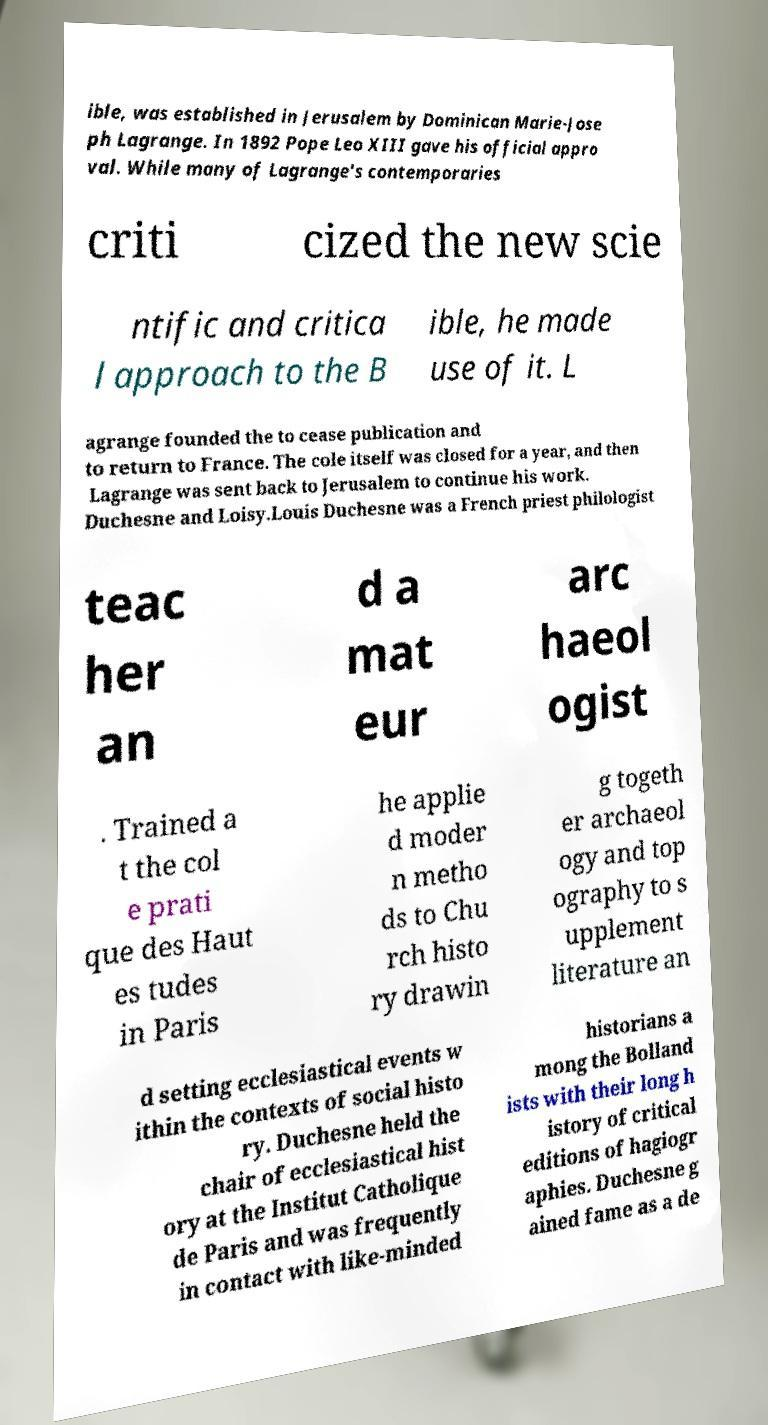Please identify and transcribe the text found in this image. ible, was established in Jerusalem by Dominican Marie-Jose ph Lagrange. In 1892 Pope Leo XIII gave his official appro val. While many of Lagrange's contemporaries criti cized the new scie ntific and critica l approach to the B ible, he made use of it. L agrange founded the to cease publication and to return to France. The cole itself was closed for a year, and then Lagrange was sent back to Jerusalem to continue his work. Duchesne and Loisy.Louis Duchesne was a French priest philologist teac her an d a mat eur arc haeol ogist . Trained a t the col e prati que des Haut es tudes in Paris he applie d moder n metho ds to Chu rch histo ry drawin g togeth er archaeol ogy and top ography to s upplement literature an d setting ecclesiastical events w ithin the contexts of social histo ry. Duchesne held the chair of ecclesiastical hist ory at the Institut Catholique de Paris and was frequently in contact with like-minded historians a mong the Bolland ists with their long h istory of critical editions of hagiogr aphies. Duchesne g ained fame as a de 